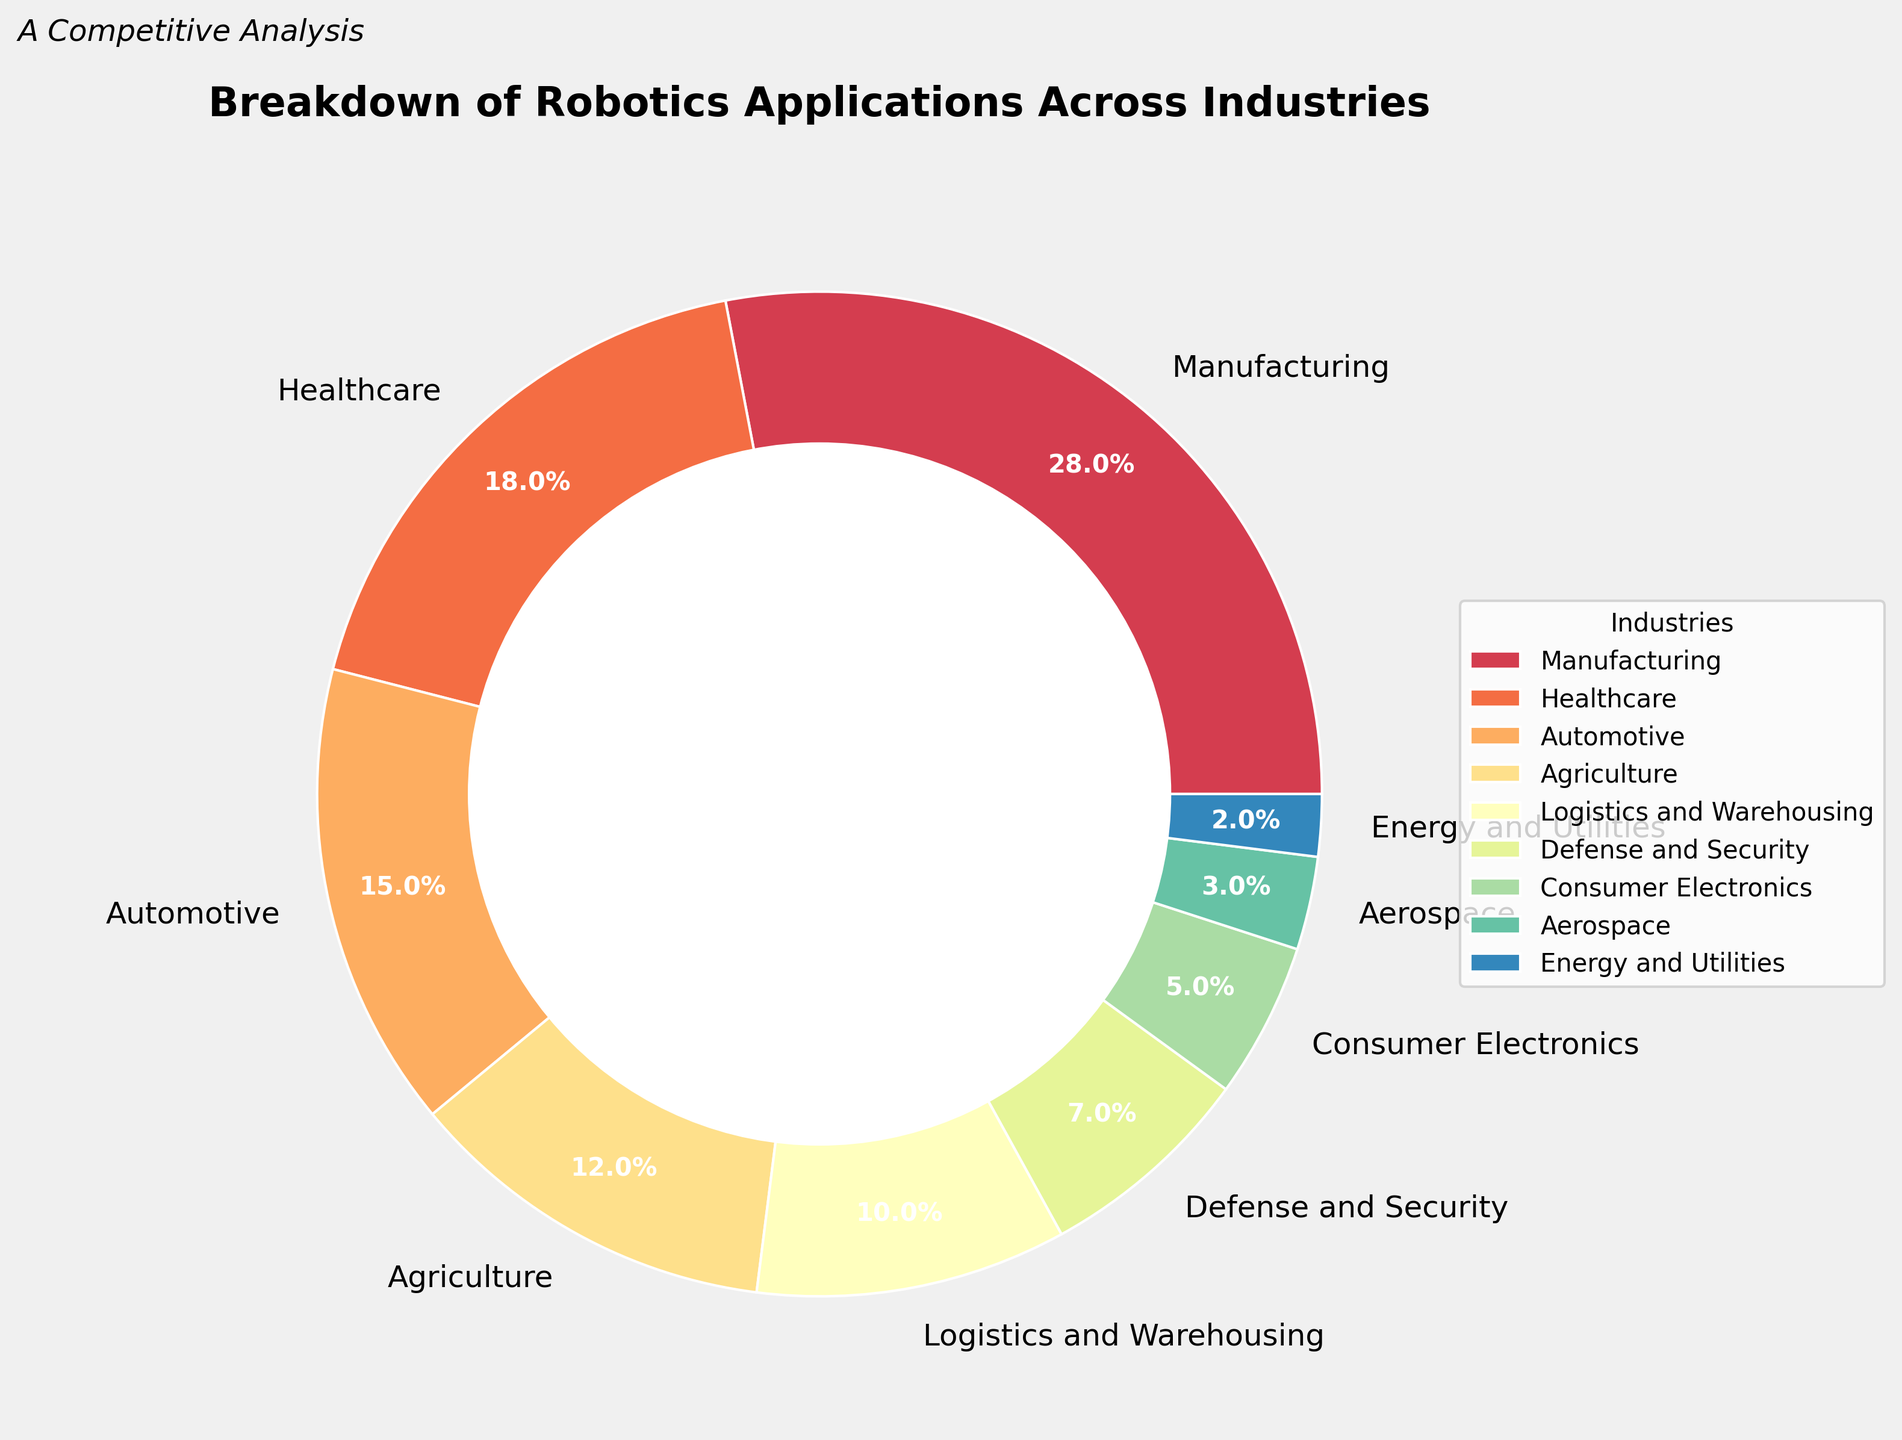Which industry has the largest application of robotics? The pie chart indicates that the Manufacturing sector has the largest slice, labeled with 28%.
Answer: Manufacturing What is the combined percentage of robotics applications in Automotive and Agriculture? According to the chart, Automotive is 15% and Agriculture is 12%. Summing these gives 15% + 12% = 27%.
Answer: 27% Which sector has a larger application of robotics, Healthcare or Logistics and Warehousing? The Healthcare sector has a larger percentage of 18% compared to Logistics and Warehousing at 10%.
Answer: Healthcare What is the difference in the percentage of robotics applications between Defense and Security and Aerospace? Defense and Security is at 7% and Aerospace is at 3%. The difference is 7% - 3% = 4%.
Answer: 4% What is the average percentage of the three smallest sectors shown in the chart? The three smallest sectors are Energy and Utilities (2%), Aerospace (3%), and Consumer Electronics (5%). The average is (2% + 3% + 5%) / 3 = 10% / 3 ≈ 3.33%.
Answer: 3.33% If the application in Manufacturing increased by 5%, what would be the new percentage for this sector? The current percentage for Manufacturing is 28%. If it increased by 5%, it would be 28% + 5% = 33%.
Answer: 33% How many sectors have a higher percentage than Defense and Security? The sectors with higher percentages than Defense and Security (7%) are Manufacturing (28%), Healthcare (18%), Automotive (15%), Agriculture (12%), and Logistics and Warehousing (10%). There are 5 such sectors.
Answer: 5 Which industry has the lightest color in the pie chart? Based on a common color scheme typically used in pie charts, lighter colors usually represent smaller percentages. This means Energy and Utilities with 2% is likely to have the lightest color.
Answer: Energy and Utilities What is the total percentage of the top three industries in terms of robotics applications? The top three industries are Manufacturing (28%), Healthcare (18%), and Automotive (15%). The total is 28% + 18% + 15% = 61%.
Answer: 61% 